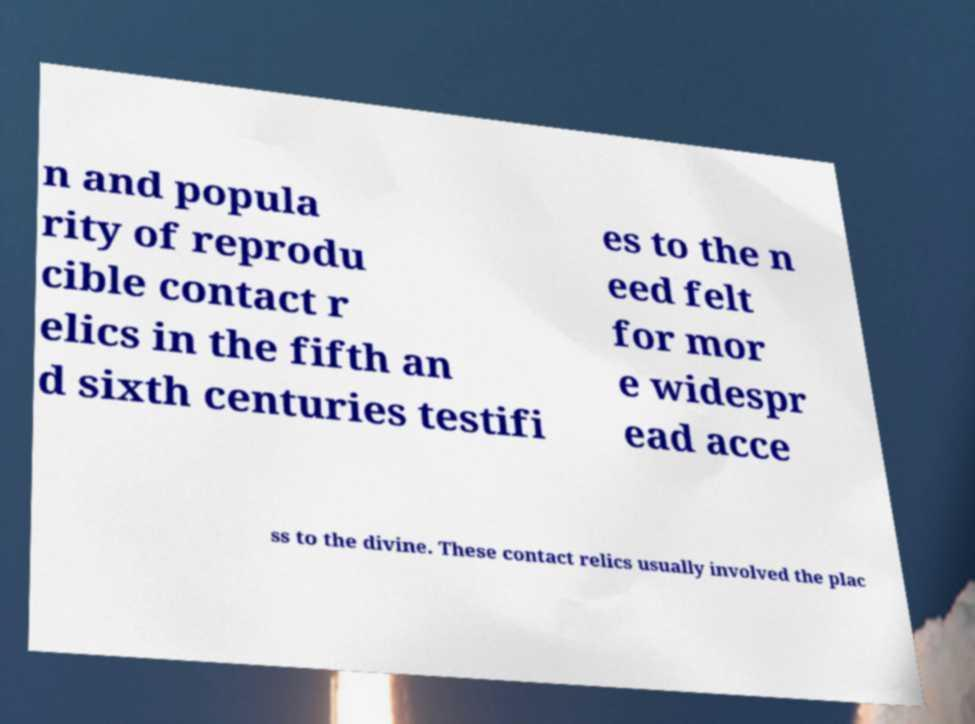Could you extract and type out the text from this image? n and popula rity of reprodu cible contact r elics in the fifth an d sixth centuries testifi es to the n eed felt for mor e widespr ead acce ss to the divine. These contact relics usually involved the plac 